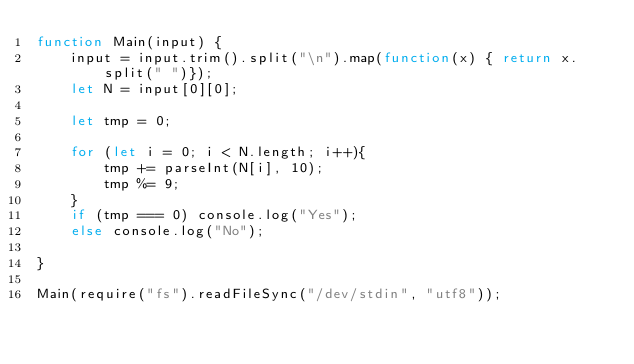Convert code to text. <code><loc_0><loc_0><loc_500><loc_500><_JavaScript_>function Main(input) {
    input = input.trim().split("\n").map(function(x) { return x.split(" ")});
    let N = input[0][0];

    let tmp = 0;

    for (let i = 0; i < N.length; i++){
        tmp += parseInt(N[i], 10);
        tmp %= 9;
    }
    if (tmp === 0) console.log("Yes");
    else console.log("No");

}

Main(require("fs").readFileSync("/dev/stdin", "utf8"));
</code> 